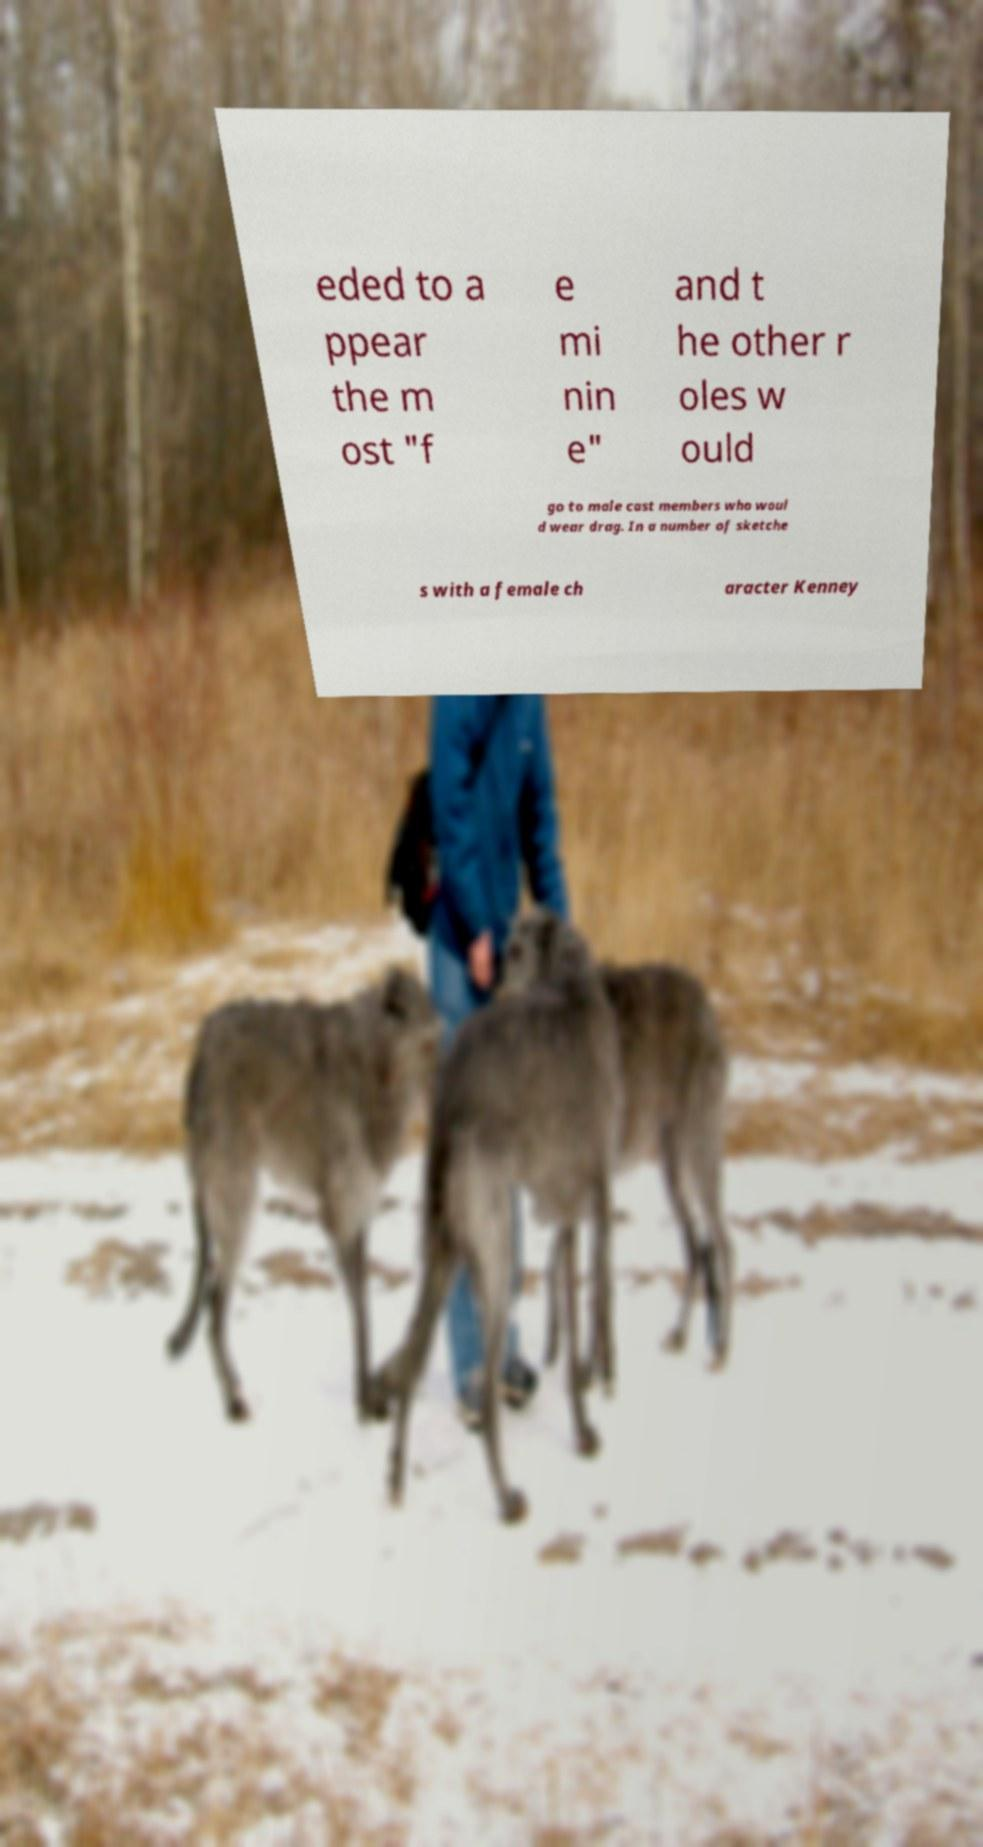Could you assist in decoding the text presented in this image and type it out clearly? eded to a ppear the m ost "f e mi nin e" and t he other r oles w ould go to male cast members who woul d wear drag. In a number of sketche s with a female ch aracter Kenney 